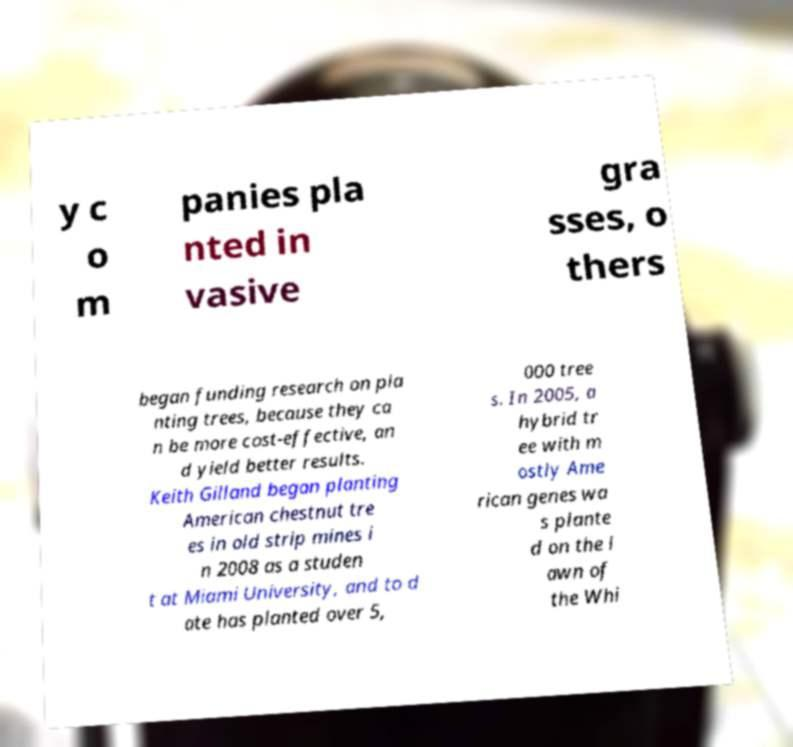Please identify and transcribe the text found in this image. y c o m panies pla nted in vasive gra sses, o thers began funding research on pla nting trees, because they ca n be more cost-effective, an d yield better results. Keith Gilland began planting American chestnut tre es in old strip mines i n 2008 as a studen t at Miami University, and to d ate has planted over 5, 000 tree s. In 2005, a hybrid tr ee with m ostly Ame rican genes wa s plante d on the l awn of the Whi 